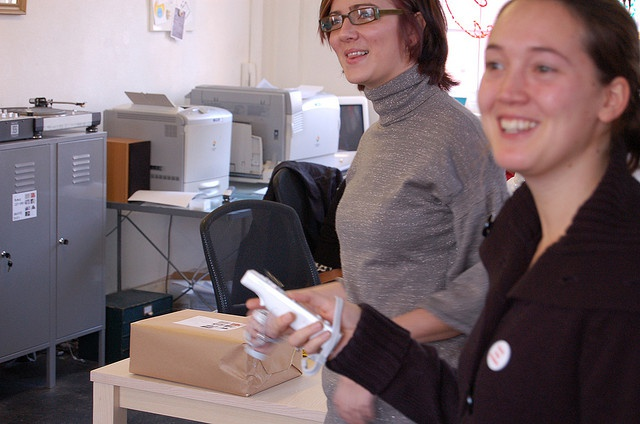Describe the objects in this image and their specific colors. I can see people in lightgray, black, brown, salmon, and darkgray tones, people in lightgray, gray, and black tones, chair in lightgray, black, and gray tones, backpack in lightgray, black, gray, and maroon tones, and remote in lightgray, lavender, darkgray, and gray tones in this image. 